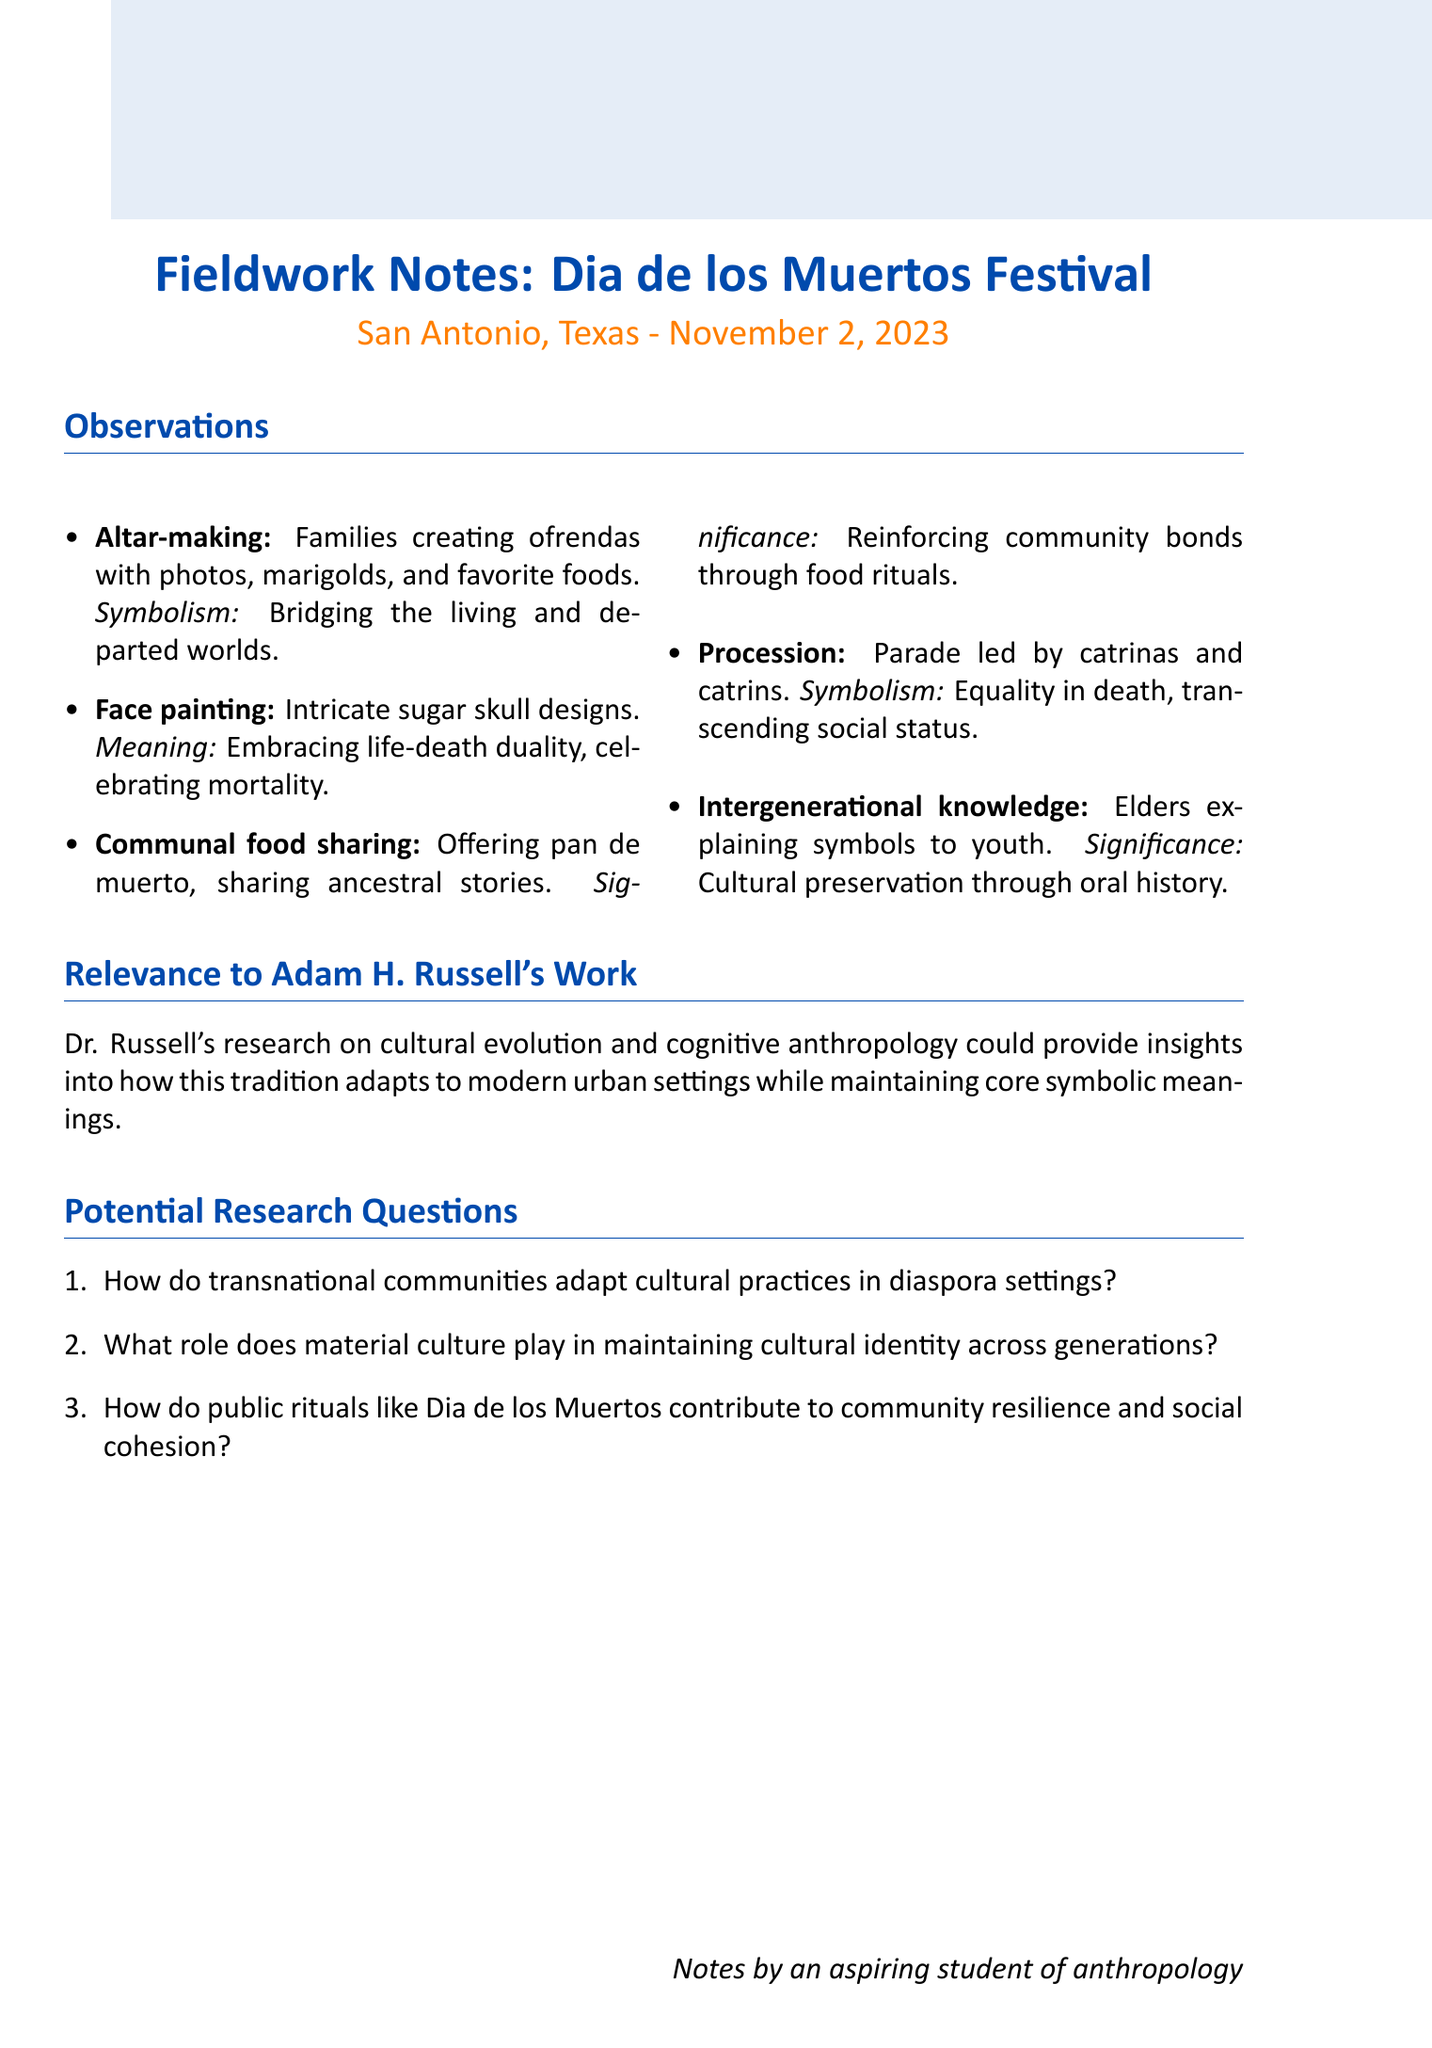what is the event name? The event name can be found at the beginning of the document under the title section.
Answer: Dia de los Muertos Festival in San Antonio, Texas when did the event take place? The date of the event is specified in the document’s opening.
Answer: November 2, 2023 where was the event held? The location of the event is provided in the introductory information of the document.
Answer: La Villita Historic Arts Village what is the symbolic meaning of altar-making? The symbolic meaning is outlined in the observation points detailing each custom.
Answer: Honoring and remembering the dead, bridging the world of the living and the departed which custom involves offering pan de muerto? This custom is explicitly mentioned in the section on communal food sharing.
Answer: Communal food sharing what does the procession symbolize? The symbolic meaning of the procession is specified under the observation points.
Answer: Representing the equality of all in death, regardless of social status in life how do elders contribute at the festival? This contribution is described in the intergenerational knowledge transfer section.
Answer: Explaining the significance of various symbols and practices what anthropological significance is associated with communal food sharing? This significance is explicitly stated in the observation related to food sharing.
Answer: Reinforcing community bonds and collective memory through food rituals how many potential research questions are listed? The number of research questions can be counted in the dedicated section of the document.
Answer: Three 